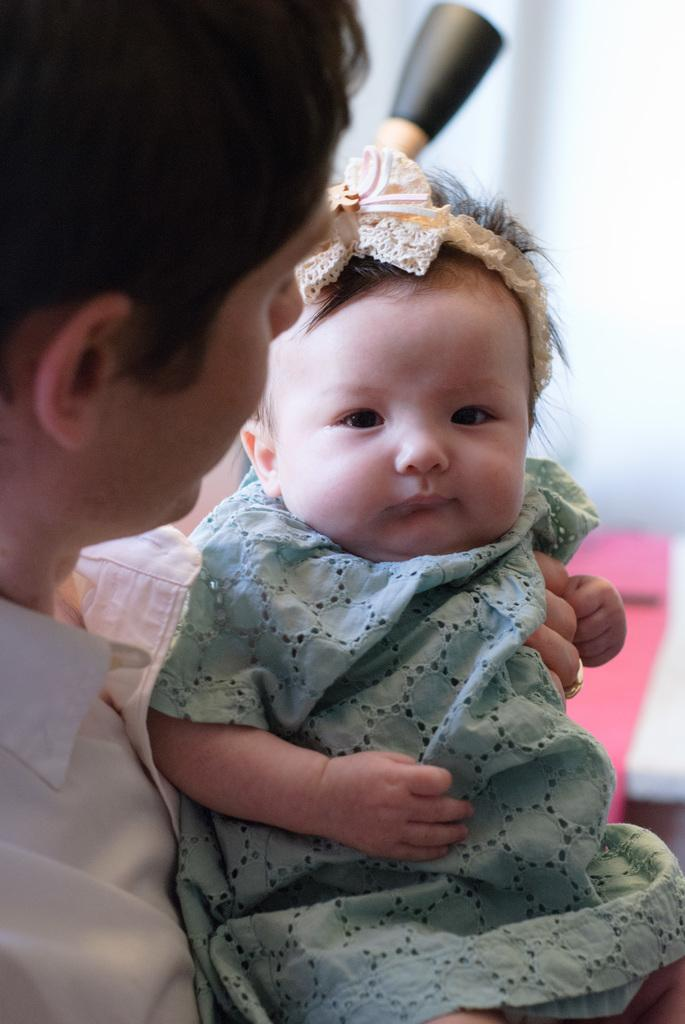What is the main subject of the image? The main subject of the image is a person holding a baby. Can you describe the background of the image? The background of the image is blurred. What type of breakfast is being prepared in the image? There is no indication of breakfast or any food preparation in the image. What fruit can be seen in the image? There is no fruit present in the image. 